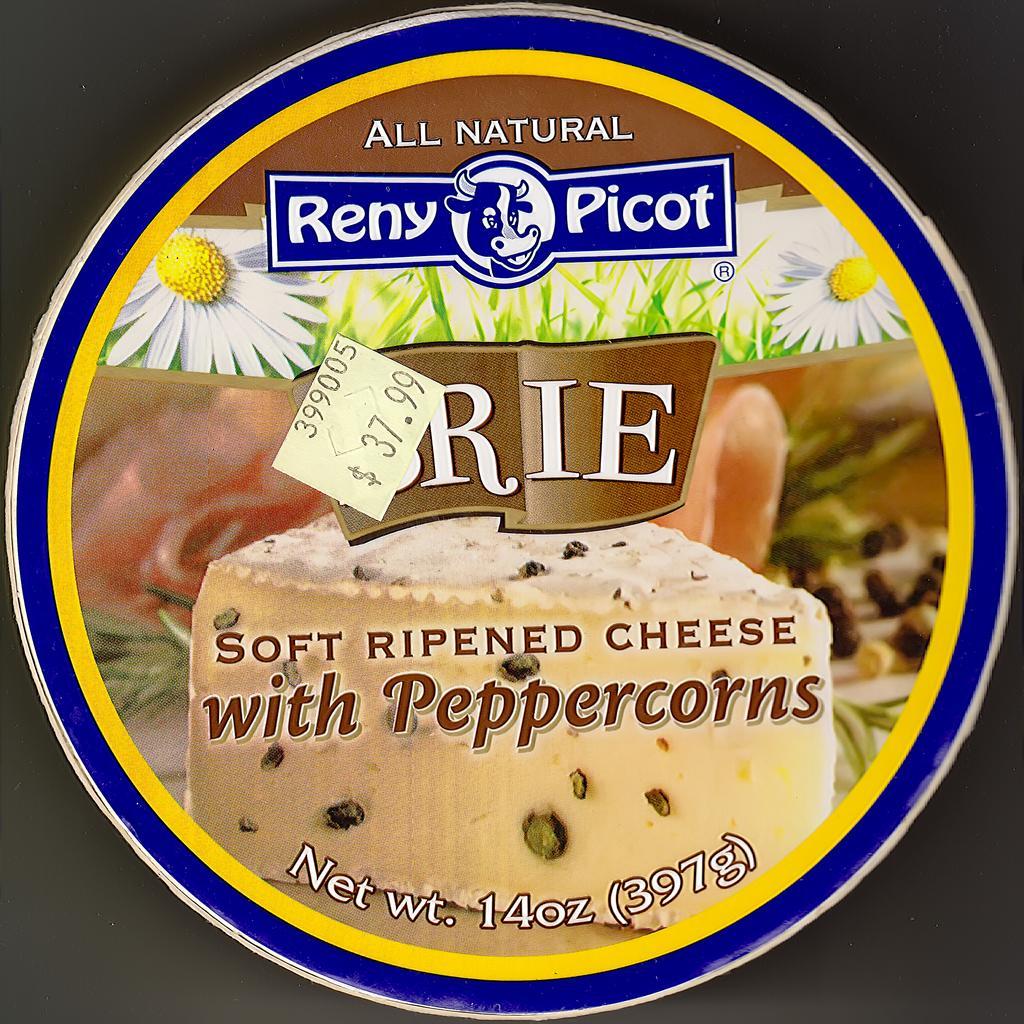Describe this image in one or two sentences. In this image All natural reny picot and soft ripened cheese with peppercorns is written with a net weight of 397gms and prized 37. 99$, they are flowers and cheese on it and it is round in shape. 